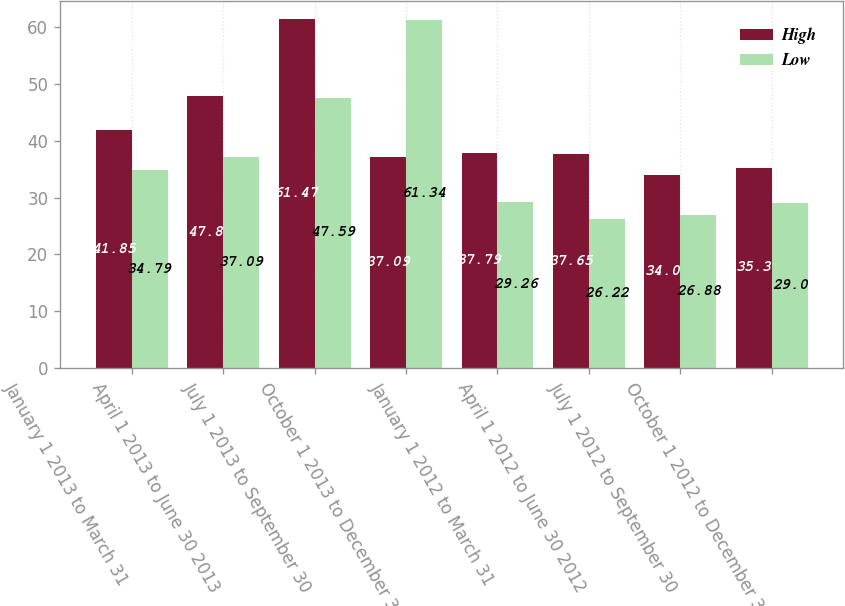Convert chart. <chart><loc_0><loc_0><loc_500><loc_500><stacked_bar_chart><ecel><fcel>January 1 2013 to March 31<fcel>April 1 2013 to June 30 2013<fcel>July 1 2013 to September 30<fcel>October 1 2013 to December 31<fcel>January 1 2012 to March 31<fcel>April 1 2012 to June 30 2012<fcel>July 1 2012 to September 30<fcel>October 1 2012 to December 31<nl><fcel>High<fcel>41.85<fcel>47.8<fcel>61.47<fcel>37.09<fcel>37.79<fcel>37.65<fcel>34<fcel>35.3<nl><fcel>Low<fcel>34.79<fcel>37.09<fcel>47.59<fcel>61.34<fcel>29.26<fcel>26.22<fcel>26.88<fcel>29<nl></chart> 